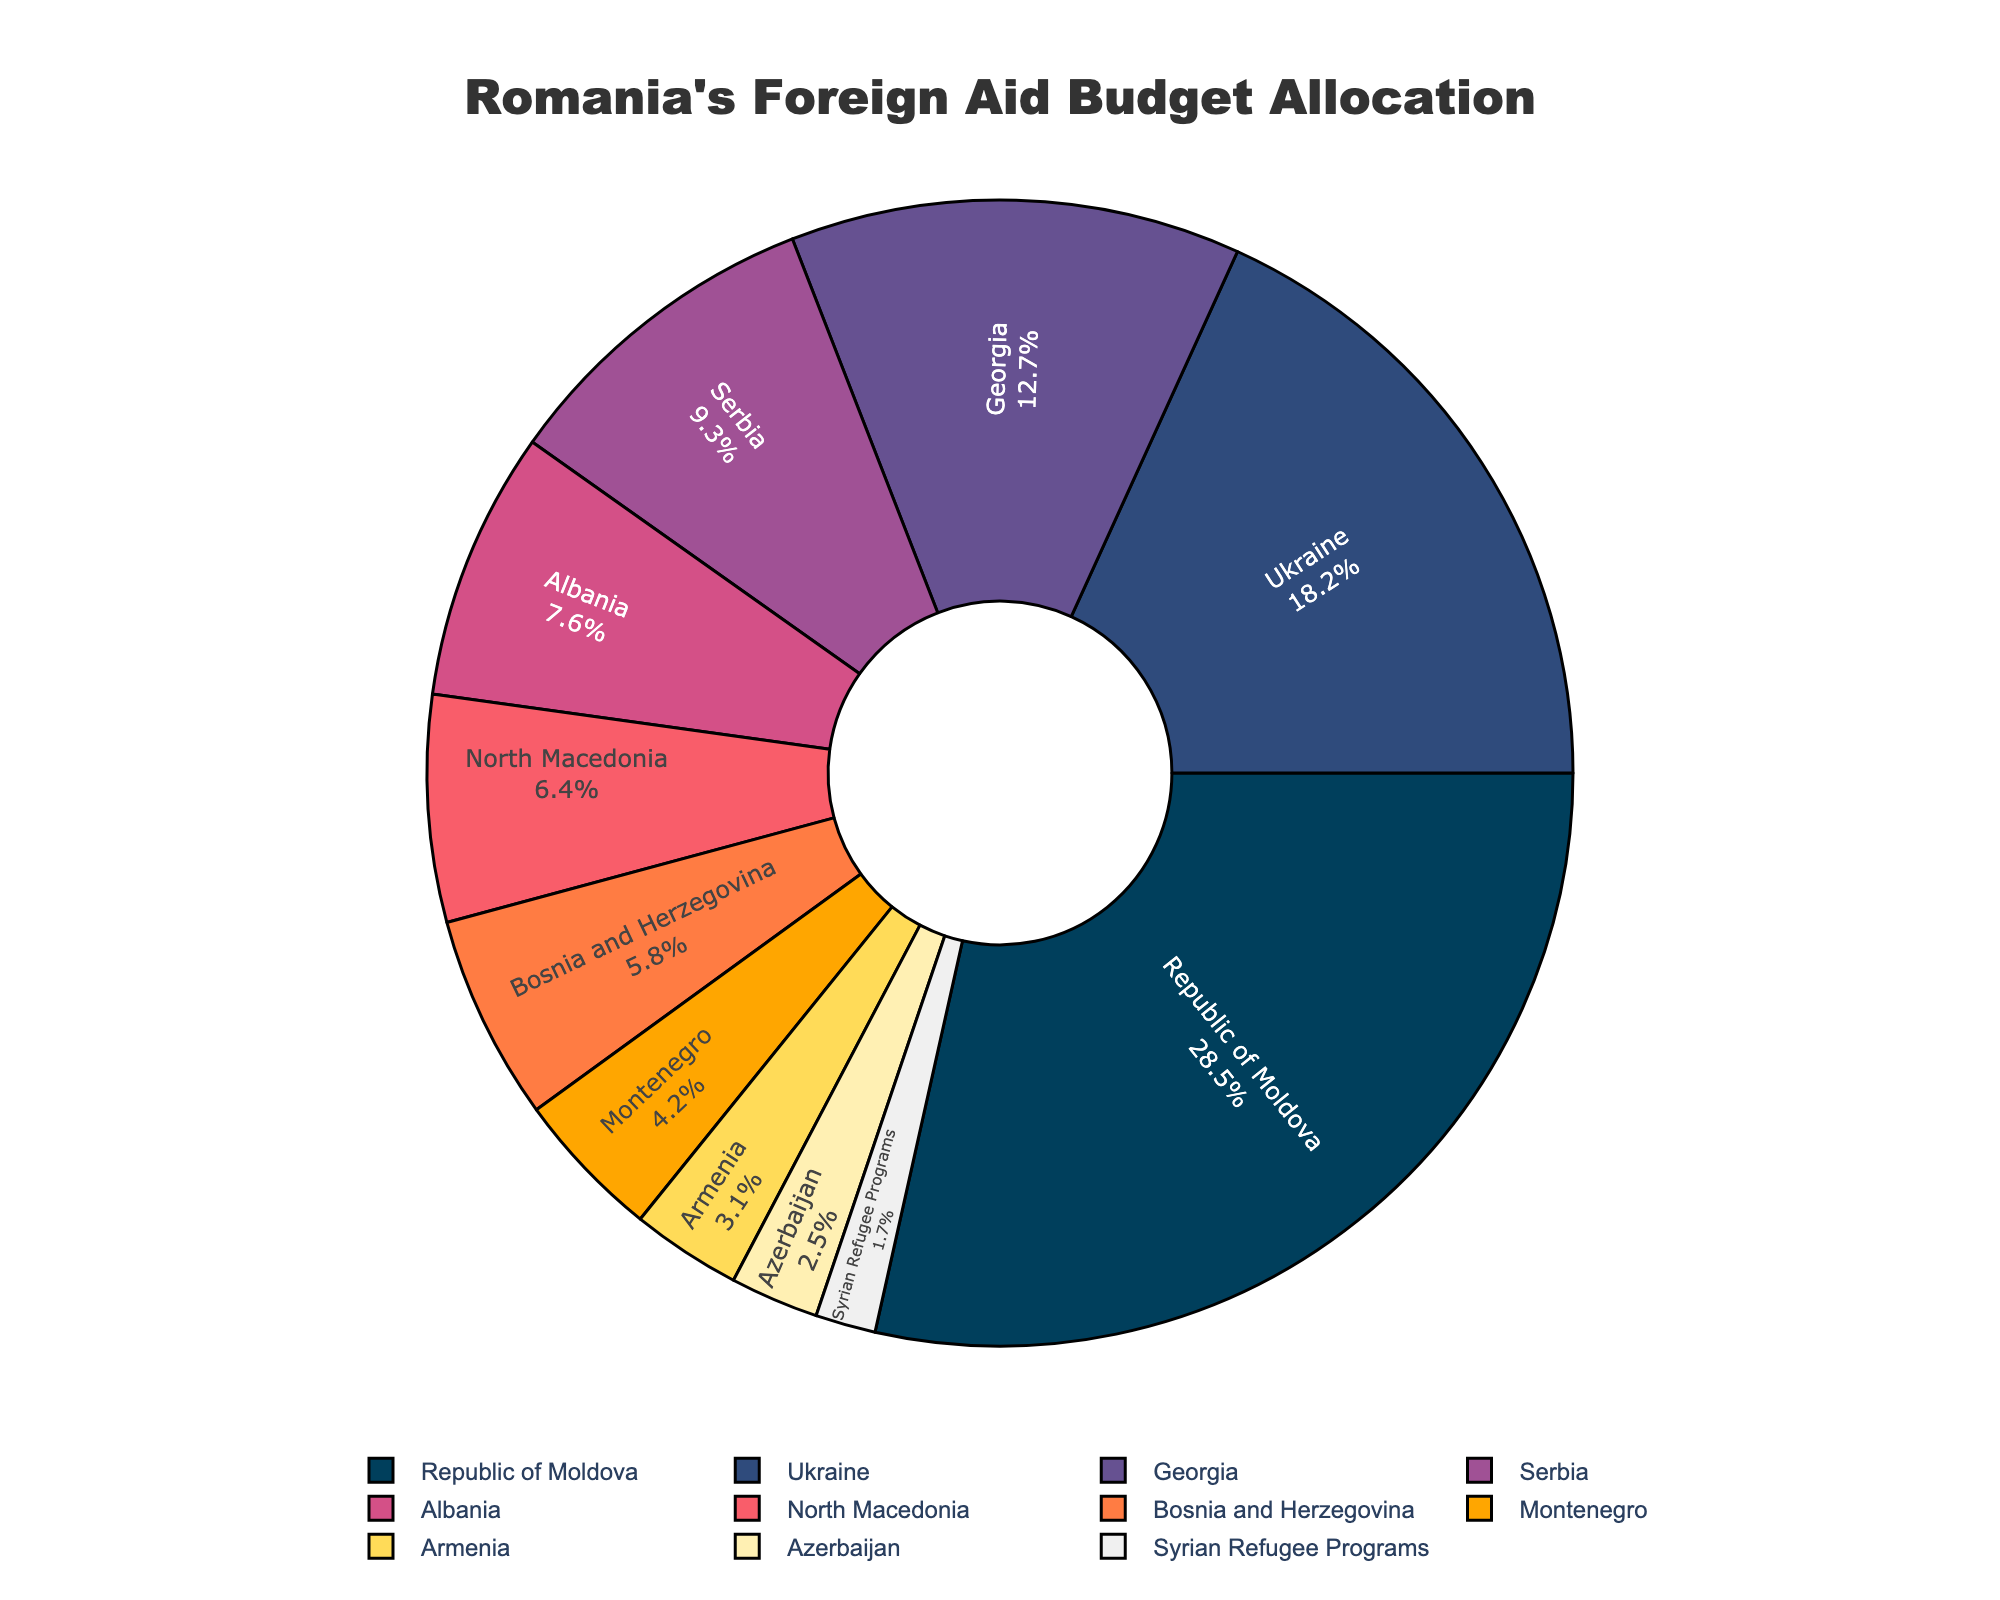What percentage of Romania's foreign aid goes to the top 3 recipient countries? The top 3 recipient countries are the Republic of Moldova, Ukraine, and Georgia. Adding their percentages: 28.5% + 18.2% + 12.7% = 59.4%.
Answer: 59.4% Which country receives more aid, Georgia or Serbia? According to the pie chart, Georgia receives 12.7% of the foreign aid budget, while Serbia receives 9.3%. Therefore, Georgia receives more aid.
Answer: Georgia By how many percentage points does the aid to Albania exceed that to North Macedonia? The aid percentage for Albania is 7.6%, and for North Macedonia, it is 6.4%. Subtracting these gives: 7.6% - 6.4% = 1.2%.
Answer: 1.2% What is the combined aid percentage for Bosnia and Herzegovina and Montenegro? Bosnia and Herzegovina receive 5.8% of the aid, and Montenegro receives 4.2%. Adding these together gives: 5.8% + 4.2% = 10%.
Answer: 10% Which country has the smallest share of the foreign aid budget? Referring to the pie chart, the Syrian Refugee Programs have the smallest share, which is 1.7%.
Answer: Syrian Refugee Programs What is the difference in aid allocation between Armenia and Azerbaijan? Armenia receives 3.1% of the budget, while Azerbaijan receives 2.5%. Subtracting these gives: 3.1% - 2.5% = 0.6%.
Answer: 0.6% Which visual attributes in the chart highlight the top recipient of the foreign aid budget? The top recipient, the Republic of Moldova, is highlighted by occupying the largest segment of the pie chart. Its position and the large area it covers compared to others make it visually prominent.
Answer: Largest segment How does the aid allocation for Ukraine compare to that for Albania and North Macedonia combined? Ukraine receives 18.2% of the aid budget. Albania and North Macedonia combined receive 7.6% + 6.4% = 14%. Ukraine's aid allocation is more than the combined allocation for Albania and North Macedonia.
Answer: Ukraine Which three countries receive the least aid, and what is their combined aid percentage? The three countries receiving the least aid are Armenia (3.1%), Azerbaijan (2.5%), and the Syrian Refugee Programs (1.7%). Adding these together gives: 3.1% + 2.5% + 1.7% = 7.3%.
Answer: 7.3% What can be observed from the color scheme of the aid allocation? The color scheme transitions from dark (largest portions) to light (smallest portions), helping to visually distinguish different aid percentages more clearly. The darker segments are for the higher percentages.
Answer: Gradual transition from dark to light 